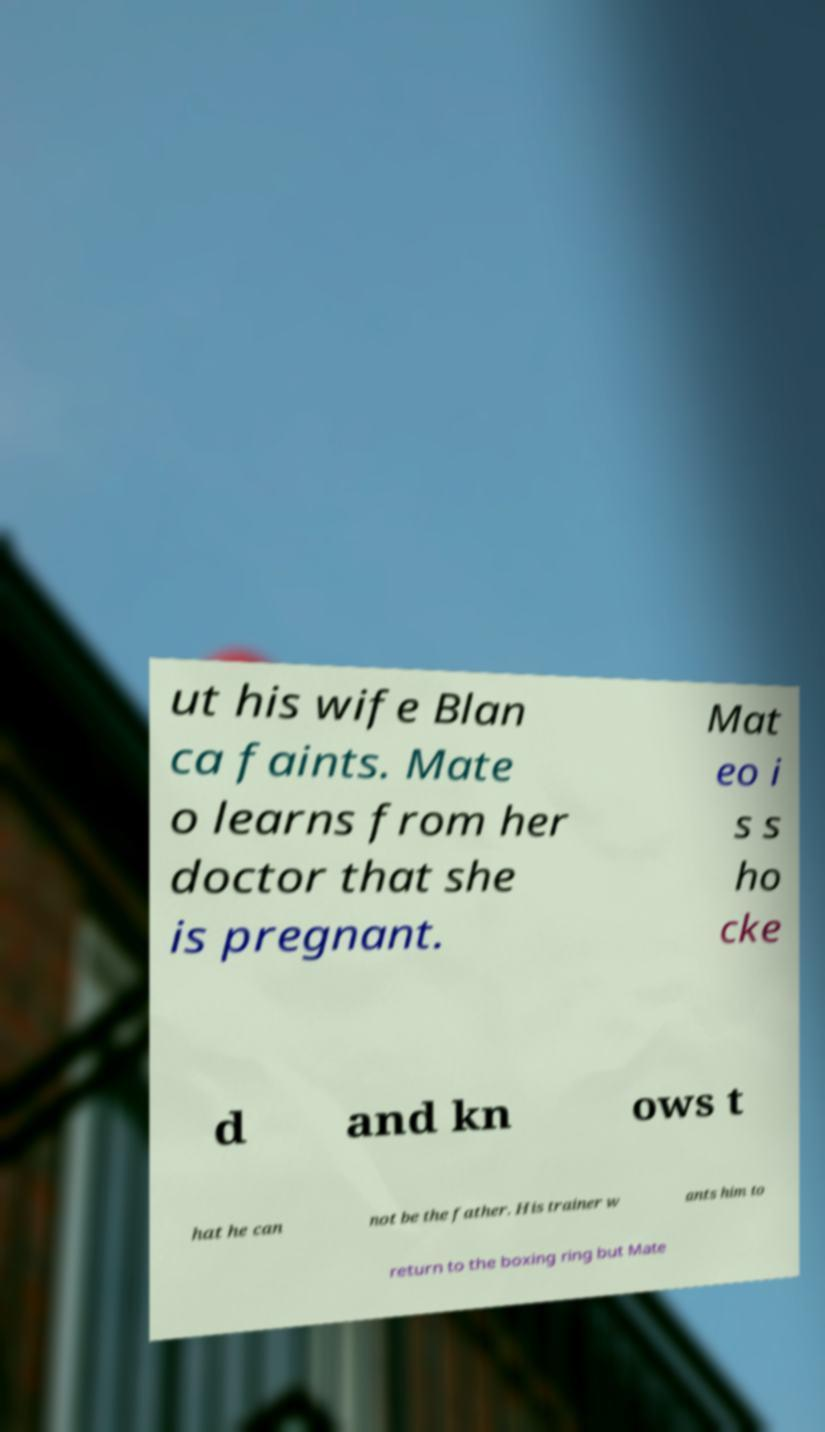I need the written content from this picture converted into text. Can you do that? ut his wife Blan ca faints. Mate o learns from her doctor that she is pregnant. Mat eo i s s ho cke d and kn ows t hat he can not be the father. His trainer w ants him to return to the boxing ring but Mate 